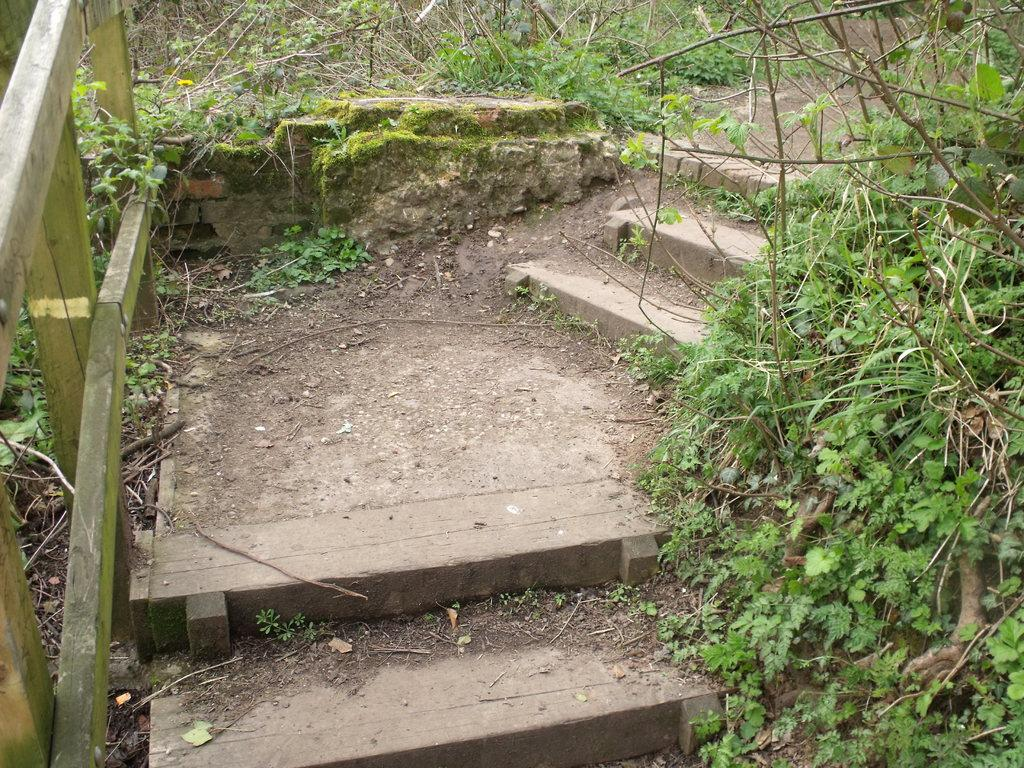What can be seen in the image that people use to move between different levels? There are stairs in the image that people use to move between different levels. What is present on both sides of the stairs to enhance their appearance or provide support? There are plants and sticks on both sides of the stairs. What material is used to construct the railing on the left side of the stairs? The railing on the left side of the stairs is made of wood. How does the turkey contribute to the stability of the stairs in the image? There is no turkey present in the image, so it cannot contribute to the stability of the stairs. 